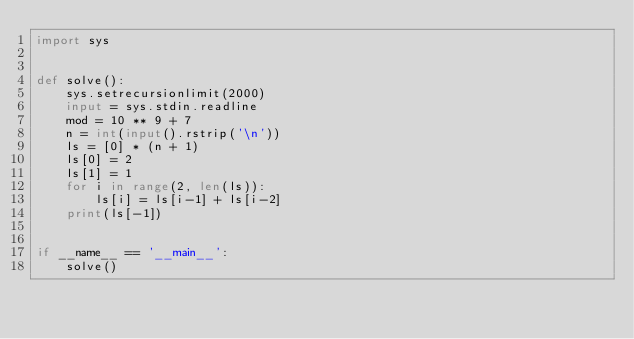<code> <loc_0><loc_0><loc_500><loc_500><_Python_>import sys


def solve():
    sys.setrecursionlimit(2000)
    input = sys.stdin.readline
    mod = 10 ** 9 + 7
    n = int(input().rstrip('\n'))
    ls = [0] * (n + 1)
    ls[0] = 2
    ls[1] = 1
    for i in range(2, len(ls)):
        ls[i] = ls[i-1] + ls[i-2]
    print(ls[-1])


if __name__ == '__main__':
    solve()
</code> 